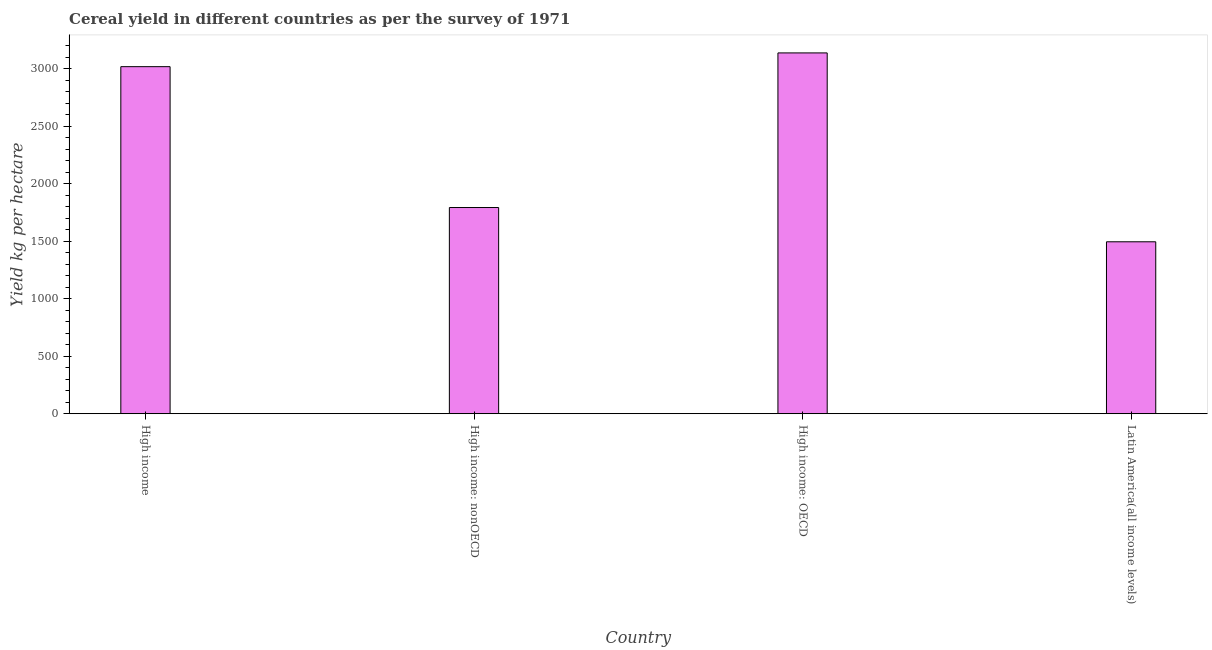Does the graph contain any zero values?
Keep it short and to the point. No. Does the graph contain grids?
Offer a terse response. No. What is the title of the graph?
Give a very brief answer. Cereal yield in different countries as per the survey of 1971. What is the label or title of the X-axis?
Provide a succinct answer. Country. What is the label or title of the Y-axis?
Offer a very short reply. Yield kg per hectare. What is the cereal yield in High income: OECD?
Give a very brief answer. 3136.65. Across all countries, what is the maximum cereal yield?
Your answer should be compact. 3136.65. Across all countries, what is the minimum cereal yield?
Provide a succinct answer. 1494.78. In which country was the cereal yield maximum?
Give a very brief answer. High income: OECD. In which country was the cereal yield minimum?
Provide a succinct answer. Latin America(all income levels). What is the sum of the cereal yield?
Provide a short and direct response. 9441.25. What is the difference between the cereal yield in High income: OECD and Latin America(all income levels)?
Offer a terse response. 1641.87. What is the average cereal yield per country?
Offer a very short reply. 2360.31. What is the median cereal yield?
Ensure brevity in your answer.  2404.91. In how many countries, is the cereal yield greater than 2300 kg per hectare?
Your answer should be very brief. 2. What is the ratio of the cereal yield in High income: nonOECD to that in Latin America(all income levels)?
Ensure brevity in your answer.  1.2. What is the difference between the highest and the second highest cereal yield?
Your response must be concise. 119.54. Is the sum of the cereal yield in High income and Latin America(all income levels) greater than the maximum cereal yield across all countries?
Your response must be concise. Yes. What is the difference between the highest and the lowest cereal yield?
Offer a terse response. 1641.87. How many bars are there?
Give a very brief answer. 4. What is the difference between two consecutive major ticks on the Y-axis?
Ensure brevity in your answer.  500. Are the values on the major ticks of Y-axis written in scientific E-notation?
Give a very brief answer. No. What is the Yield kg per hectare in High income?
Keep it short and to the point. 3017.11. What is the Yield kg per hectare in High income: nonOECD?
Your answer should be very brief. 1792.7. What is the Yield kg per hectare of High income: OECD?
Make the answer very short. 3136.65. What is the Yield kg per hectare of Latin America(all income levels)?
Your answer should be very brief. 1494.78. What is the difference between the Yield kg per hectare in High income and High income: nonOECD?
Your response must be concise. 1224.42. What is the difference between the Yield kg per hectare in High income and High income: OECD?
Your response must be concise. -119.54. What is the difference between the Yield kg per hectare in High income and Latin America(all income levels)?
Keep it short and to the point. 1522.33. What is the difference between the Yield kg per hectare in High income: nonOECD and High income: OECD?
Offer a very short reply. -1343.95. What is the difference between the Yield kg per hectare in High income: nonOECD and Latin America(all income levels)?
Your answer should be compact. 297.91. What is the difference between the Yield kg per hectare in High income: OECD and Latin America(all income levels)?
Give a very brief answer. 1641.87. What is the ratio of the Yield kg per hectare in High income to that in High income: nonOECD?
Make the answer very short. 1.68. What is the ratio of the Yield kg per hectare in High income to that in High income: OECD?
Your answer should be very brief. 0.96. What is the ratio of the Yield kg per hectare in High income to that in Latin America(all income levels)?
Offer a terse response. 2.02. What is the ratio of the Yield kg per hectare in High income: nonOECD to that in High income: OECD?
Provide a short and direct response. 0.57. What is the ratio of the Yield kg per hectare in High income: nonOECD to that in Latin America(all income levels)?
Make the answer very short. 1.2. What is the ratio of the Yield kg per hectare in High income: OECD to that in Latin America(all income levels)?
Offer a terse response. 2.1. 